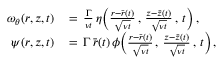<formula> <loc_0><loc_0><loc_500><loc_500>\begin{array} { r l } { \omega _ { \theta } ( r , z , t ) \, } & { = \, \frac { \Gamma } { \nu t } \, \eta \left ( \frac { r - \bar { r } ( t ) } { \sqrt { \nu t } } \, , \, \frac { z - \bar { z } ( t ) } { \sqrt { \nu t } } \, , \, t \right ) \, , } \\ { \psi ( r , z , t ) \, } & { = \, \Gamma \, \bar { r } ( t ) \, \phi \left ( \frac { r - \bar { r } ( t ) } { \sqrt { \nu t } } \, , \, \frac { z - \bar { z } ( t ) } { \sqrt { \nu t } } \, , \, t \right ) \, , } \end{array}</formula> 